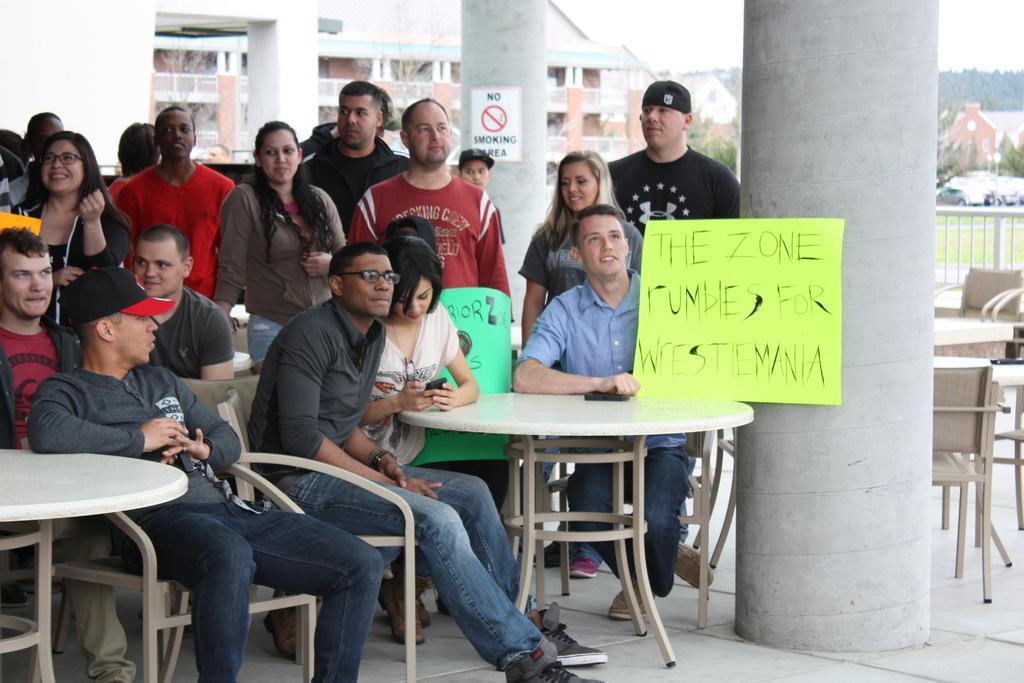How would you summarize this image in a sentence or two? Some people are sitting and standing with banners. And there are some tables and chairs there. Some pillars are there. And in one pillar one notice is kept. In the background there are some buildings. 